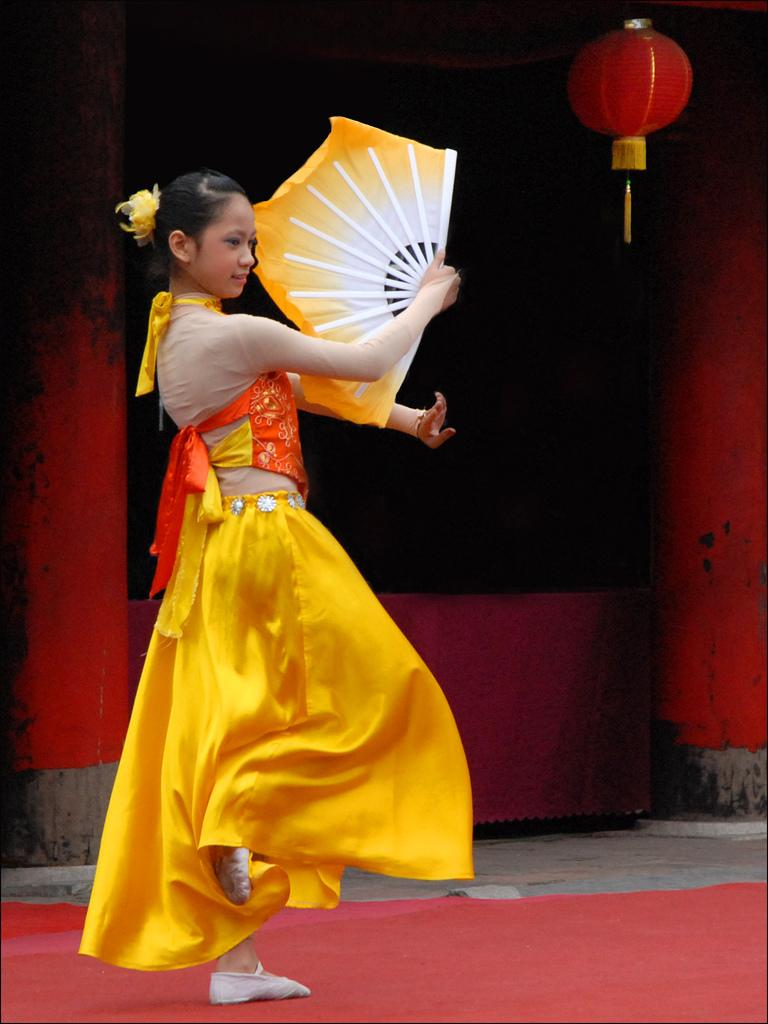Who is the main subject in the image? There is a girl in the image. What is the girl doing in the image? The girl is standing in the image. What object is the girl holding in her hand? The girl is holding a hand fan in her hand. What color is the dress the girl is wearing? The girl is wearing a yellow color dress. What is on the ground beneath the girl? There is a red carpet on the ground. What type of farm animals can be seen in the image? There are no farm animals present in the image. What is the girl using to cook in the image? There is no pan or cooking activity depicted in the image. 